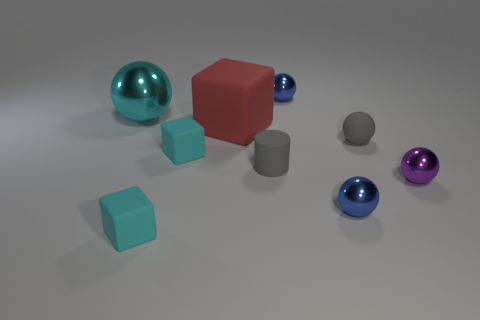Is the number of red objects to the right of the gray matte cylinder the same as the number of yellow metal blocks?
Provide a succinct answer. Yes. How many other objects are the same shape as the purple shiny object?
Ensure brevity in your answer.  4. There is a cylinder; what number of tiny blue shiny objects are in front of it?
Provide a short and direct response. 1. There is a shiny object that is both left of the small purple object and in front of the cyan ball; how big is it?
Offer a terse response. Small. Is there a small cyan rubber thing?
Ensure brevity in your answer.  Yes. What number of other objects are the same size as the gray matte ball?
Your response must be concise. 6. Do the tiny shiny ball right of the matte ball and the small sphere in front of the tiny purple object have the same color?
Give a very brief answer. No. What is the size of the gray thing that is the same shape as the purple shiny object?
Offer a terse response. Small. Is the material of the tiny blue sphere in front of the large cyan object the same as the tiny blue object that is behind the big red block?
Keep it short and to the point. Yes. What number of shiny things are either tiny cubes or tiny brown cylinders?
Offer a very short reply. 0. 